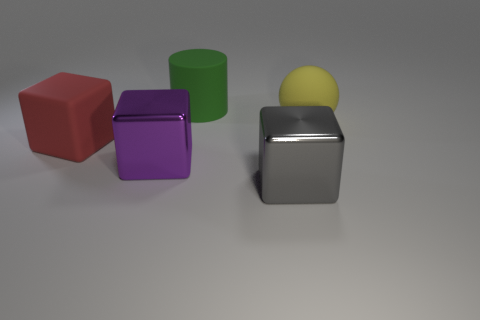Subtract all big metal cubes. How many cubes are left? 1 Subtract all purple cubes. How many cubes are left? 2 Subtract all balls. How many objects are left? 4 Add 5 big purple cylinders. How many objects exist? 10 Subtract all blue blocks. How many gray cylinders are left? 0 Subtract all red cubes. Subtract all blue cylinders. How many cubes are left? 2 Subtract all small metallic cubes. Subtract all big metallic things. How many objects are left? 3 Add 1 yellow objects. How many yellow objects are left? 2 Add 5 large green rubber cylinders. How many large green rubber cylinders exist? 6 Subtract 0 gray balls. How many objects are left? 5 